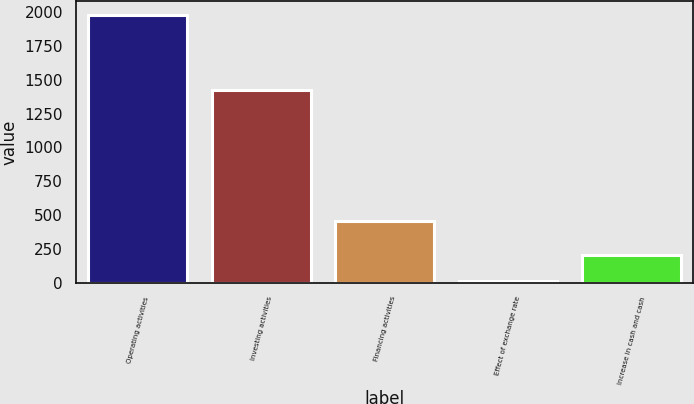Convert chart to OTSL. <chart><loc_0><loc_0><loc_500><loc_500><bar_chart><fcel>Operating activities<fcel>Investing activities<fcel>Financing activities<fcel>Effect of exchange rate<fcel>Increase in cash and cash<nl><fcel>1981<fcel>1422<fcel>459<fcel>9<fcel>206.2<nl></chart> 